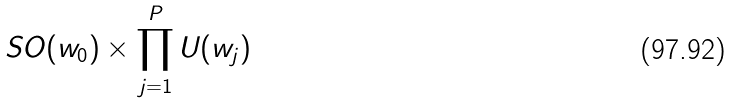<formula> <loc_0><loc_0><loc_500><loc_500>S O ( w _ { 0 } ) \times \prod _ { j = 1 } ^ { P } U ( w _ { j } )</formula> 